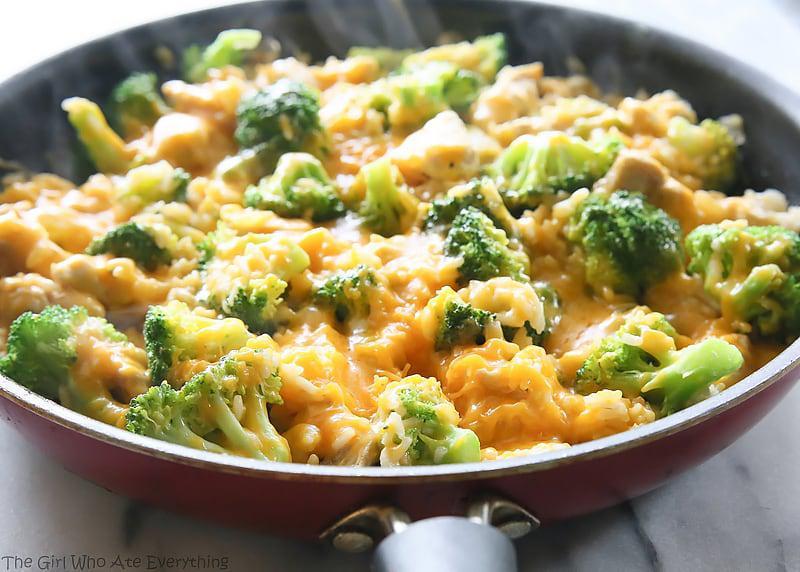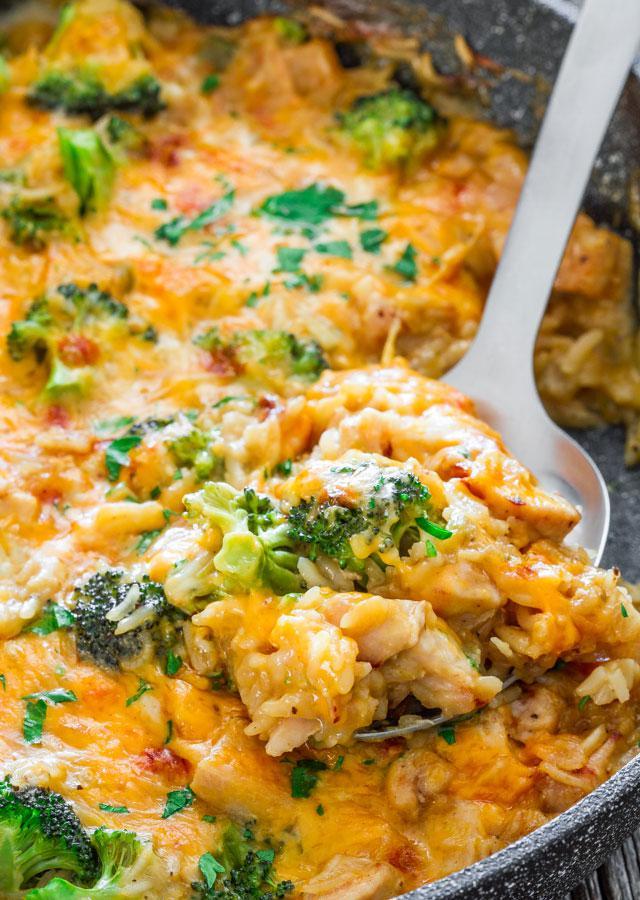The first image is the image on the left, the second image is the image on the right. For the images displayed, is the sentence "Some of the food in one image is in a spoon." factually correct? Answer yes or no. Yes. 